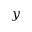Convert formula to latex. <formula><loc_0><loc_0><loc_500><loc_500>y</formula> 